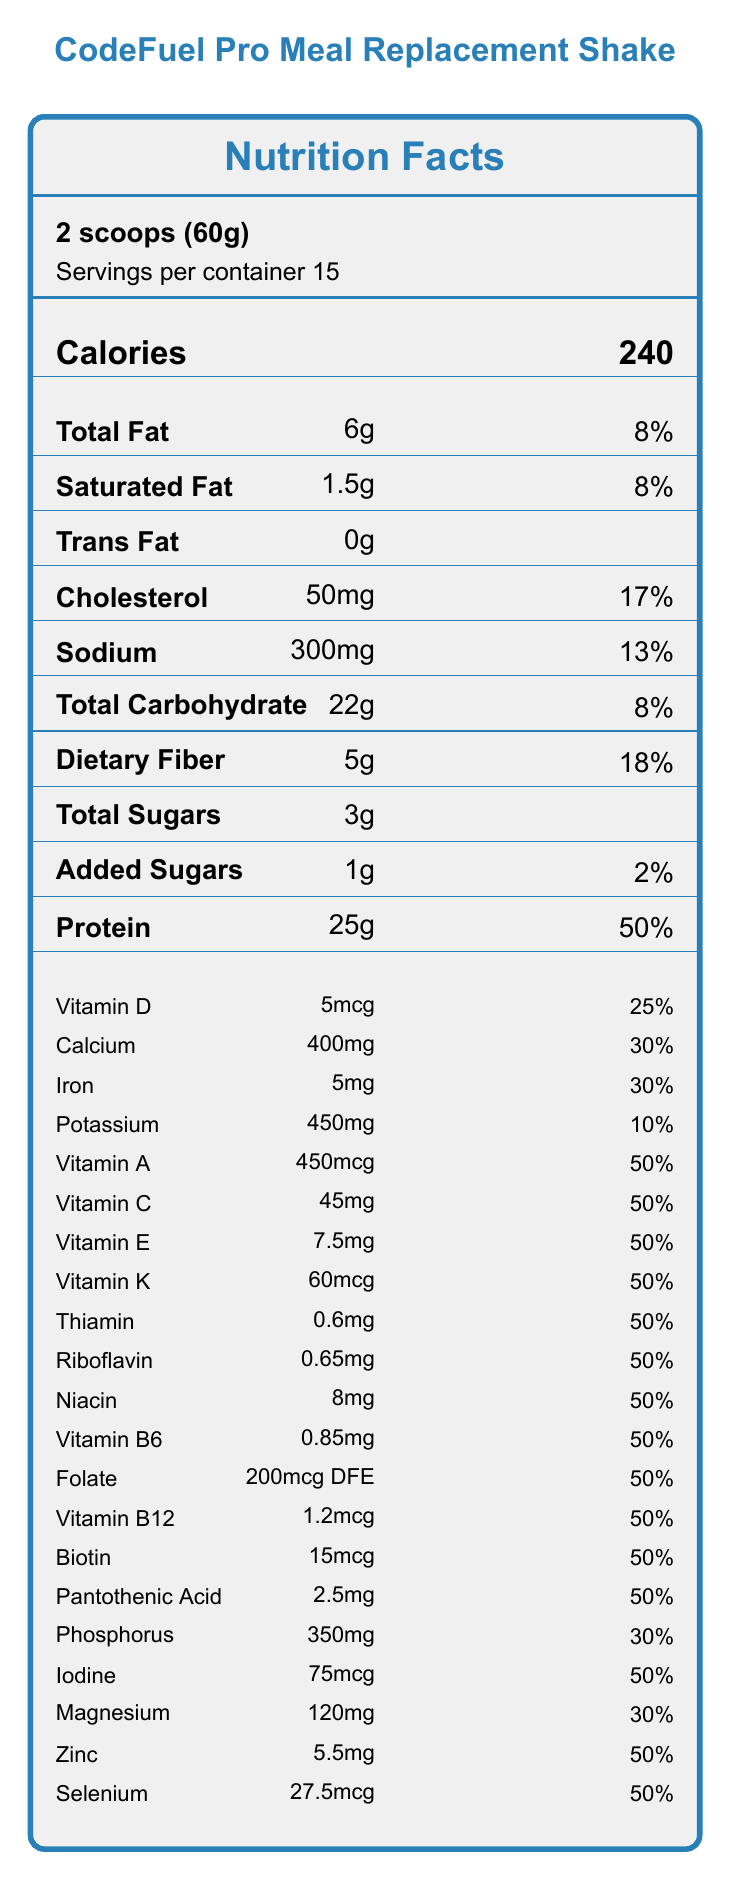what is the serving size? The serving size is specified at the top of the document as "2 scoops (60g)".
Answer: 2 scoops (60g) how many calories are there in one serving? The calories per serving are clearly mentioned as "240" under the "Calories" section.
Answer: 240 how much protein is in one serving? The protein content per serving is listed as "25g" under the "Protein" section.
Answer: 25g how many servings are there per container? The servings per container are specified at the top of the document as "Servings per container 15".
Answer: 15 what is the total fat content per serving? The total fat content per serving is noted as "6g" under the "Total Fat" section.
Answer: 6g which nutrient has the highest daily value percentage? A. Vitamin C B. Calcium C. Protein D. Sodium The Protein has the highest daily value percentage at 50%, as indicated in the document.
Answer: C. Protein how much added sugar is in one serving? A. 0g B. 1g C. 3g D. 5g The added sugar content is specified as "1g" under the "Added Sugars" section.
Answer: B. 1g does this product contain any allergens? The allergen information states "Contains milk. Manufactured in a facility that also processes soy, egg, tree nuts, and wheat."
Answer: Yes is this product suitable for someone who is lactose intolerant? The document states that it contains milk, but does not provide further details on lactose content or suitability for lactose-intolerant individuals.
Answer: Not enough information how long is the shelf life of this product? The shelf life is stated as "18 months when stored in a cool, dry place".
Answer: 18 months describe the entire document. The explanation summarizes the key elements found in the document, touching on all the major sections described in the label.
Answer: The document is a Nutrition Facts Label for the "CodeFuel Pro Meal Replacement Shake". It includes information about serving size, calories, macronutrients, micronutrients, ingredients, allergen information, shelf life, preparation instructions, and sustainability info. The label emphasizes the high protein content and its benefits for sustained energy and cognitive function. how much sodium is in one serving? The sodium content per serving is listed as "300mg" under the "Sodium" section.
Answer: 300mg what is the daily value percentage for iron? The daily value percentage for iron is noted as "30%" under the "Iron" section.
Answer: 30% what are the main sources of protein in this shake? The ingredients list specifies these as the sources of protein.
Answer: Whey Protein Isolate, Pea Protein, Brown Rice Protein how much calcium is in one serving? The calcium content per serving is listed as "400mg" under the "Calcium" section.
Answer: 400mg 